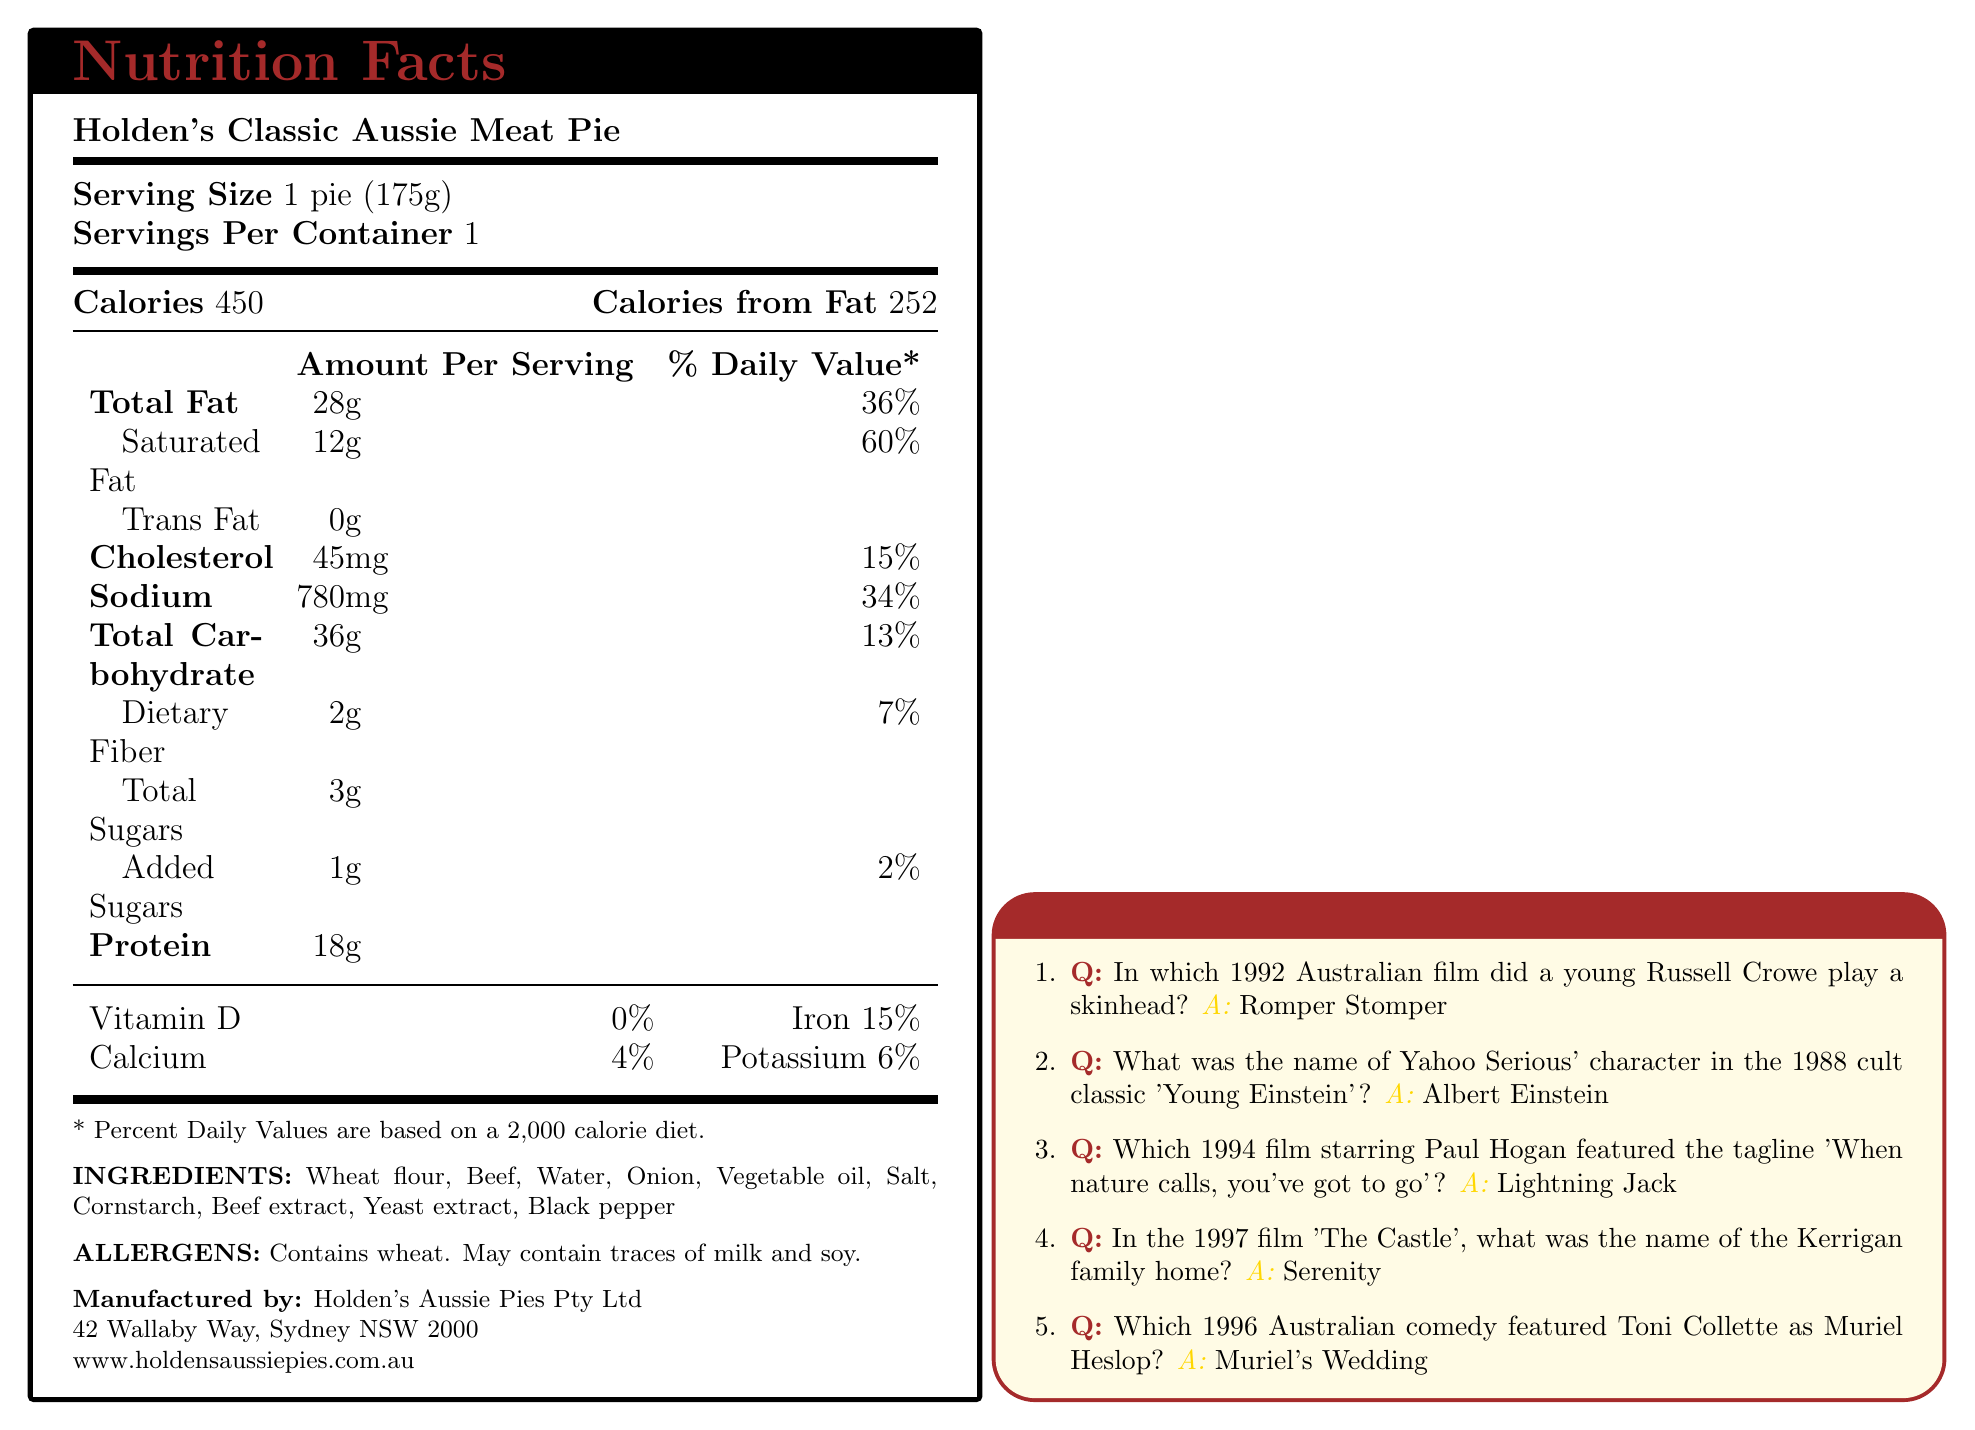what is the serving size of Holden's Classic Aussie Meat Pie? The document states the serving size as "1 pie (175g)."
Answer: 1 pie (175g) how many calories are in one serving of the meat pie? According to the document, there are 450 calories per serving in Holden's Classic Aussie Meat Pie.
Answer: 450 what percentage of the daily value of saturated fat is in one serving of the meat pie? The nutrition facts section lists saturated fat as 12g, which is 60% of the daily value.
Answer: 60% what is the amount of sodium contained in each serving? The amount of sodium per serving is indicated as 780mg in the document.
Answer: 780mg name one ingredient used in Holden's Classic Aussie Meat Pie. The ingredients list includes wheat flour along with several other components such as beef, water, onion, etc.
Answer: Wheat flour which vitamin does the meat pie neither contain nor contribute to daily value? A. Vitamin D B. Calcium C. Iron D. Potassium The document lists vitamin D at 0% daily value, indicating it does not contribute to this vitamin.
Answer: A. Vitamin D which 90s Australian comedy featured Toni Collette as Muriel Heslop? A. Romper Stomper B. Young Einstein C. Lightning Jack D. Muriel's Wedding According to the nostalgic movie trivia section, the 1996 Australian comedy "Muriel's Wedding" featured Toni Collette as Muriel Heslop.
Answer: D. Muriel's Wedding does the pie contain any trans fat? The document states that the trans fat content is 0g.
Answer: No can the Holden's Classic Aussie Meat Pie be safely consumed by someone with a soy allergy? It may not be safe as the document states that the pie may contain traces of soy.
Answer: No summarize the main content of the document. The document is a comprehensive summary of the product, giving information on its nutritional value, ingredients, allergens, and additional trivia relevant to an Australian movie enthusiast from the 90s.
Answer: This document provides the nutritional facts and ingredients for Holden's Classic Aussie Meat Pie, details its serving size, caloric content, and daily value percentages of various nutrients. It also includes a section on nostalgic 90s Australian movie trivia and contains manufacturer information. who plays a skinhead in the 1992 film, Romper Stomper? The nostalgic movie trivia section specifies that Russell Crowe played a skinhead in the 1992 Australian film, 'Romper Stomper'.
Answer: Russell Crowe what is the total carbohydrate content per serving? The nutrition facts denote the total carbohydrate amount per serving as 36g.
Answer: 36g is there any added sugar in the meat pie? The document lists 1g of added sugars.
Answer: Yes what percentage of the daily value of iron does one serving of the meat pie provide? The nutritional facts section shows that a serving provides 15% of the daily value for iron.
Answer: 15% what is the name of Yahoo Serious' character in 'Young Einstein'? The movie trivia section mentions that Yahoo Serious' character in the 1988 film 'Young Einstein' is named Albert Einstein.
Answer: Albert Einstein how many servings are in one container of the meat pie? The document states there is 1 serving per container.
Answer: 1 where is the manufacturer of Holden's Classic Aussie Meat Pie located? The manufacturer's address is provided in the document as 42 Wallaby Way, Sydney NSW 2000.
Answer: 42 Wallaby Way, Sydney NSW 2000 how much dietary fiber is there in one serving? The nutrition facts indicate that there are 2g of dietary fiber per serving.
Answer: 2g what is the protein content per serving of the meat pie? The protein content per serving is listed as 18g in the nutrition facts section.
Answer: 18g does the meat pie contain any allergens? If so, which ones? The allergens section lists wheat and mentions possible traces of milk and soy.
Answer: Yes, wheat and may contain traces of milk and soy which 1994 film starring Paul Hogan featured the tagline 'When nature calls, you've got to go'? The movie trivia section states that 'Lightning Jack' is the 1994 film featuring Paul Hogan with the tagline 'When nature calls, you've got to go'.
Answer: Lightning Jack what is the daily value percentage of calcium in one serving? The nutritional information indicates that the daily value percentage of calcium is 4%.
Answer: 4% calculate the calories from fat in one serving if the serving size information is removed. The document clearly indicates that the number of calories from fat is 252.
Answer: 252 calories from fat how many grams of total sugars are present in one serving? The nutrition facts list 3g of total sugars per serving.
Answer: 3g what was the name of the Kerrigan family home in 'The Castle'? According to the 90s Aussie movie trivia section, the Kerrigan family home in 'The Castle' was named Serenity.
Answer: Serenity is the website for Holden's Aussie Pies Pty Ltd provided in the document? The document lists the website as www.holdensaussiepies.com.au.
Answer: Yes calculate the total fat percentage based on the saturated and trans fat data. The document doesn't provide enough information to calculate the percentage as it lacks other fat components beyond saturated and trans fat.
Answer: Cannot be determined 